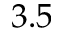<formula> <loc_0><loc_0><loc_500><loc_500>3 . 5</formula> 